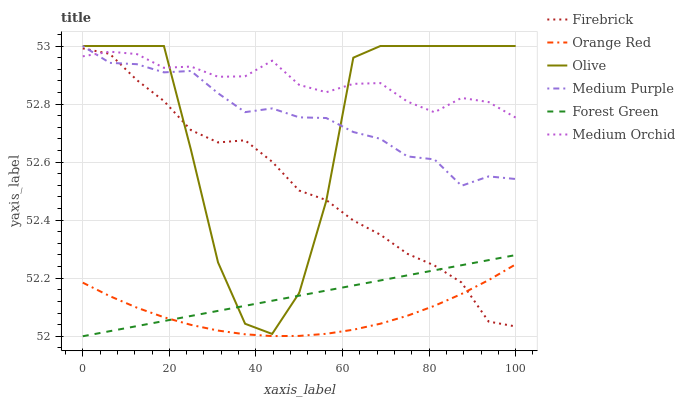Does Orange Red have the minimum area under the curve?
Answer yes or no. Yes. Does Medium Orchid have the maximum area under the curve?
Answer yes or no. Yes. Does Medium Purple have the minimum area under the curve?
Answer yes or no. No. Does Medium Purple have the maximum area under the curve?
Answer yes or no. No. Is Forest Green the smoothest?
Answer yes or no. Yes. Is Olive the roughest?
Answer yes or no. Yes. Is Medium Orchid the smoothest?
Answer yes or no. No. Is Medium Orchid the roughest?
Answer yes or no. No. Does Forest Green have the lowest value?
Answer yes or no. Yes. Does Medium Purple have the lowest value?
Answer yes or no. No. Does Olive have the highest value?
Answer yes or no. Yes. Does Medium Orchid have the highest value?
Answer yes or no. No. Is Orange Red less than Olive?
Answer yes or no. Yes. Is Medium Orchid greater than Orange Red?
Answer yes or no. Yes. Does Orange Red intersect Forest Green?
Answer yes or no. Yes. Is Orange Red less than Forest Green?
Answer yes or no. No. Is Orange Red greater than Forest Green?
Answer yes or no. No. Does Orange Red intersect Olive?
Answer yes or no. No. 